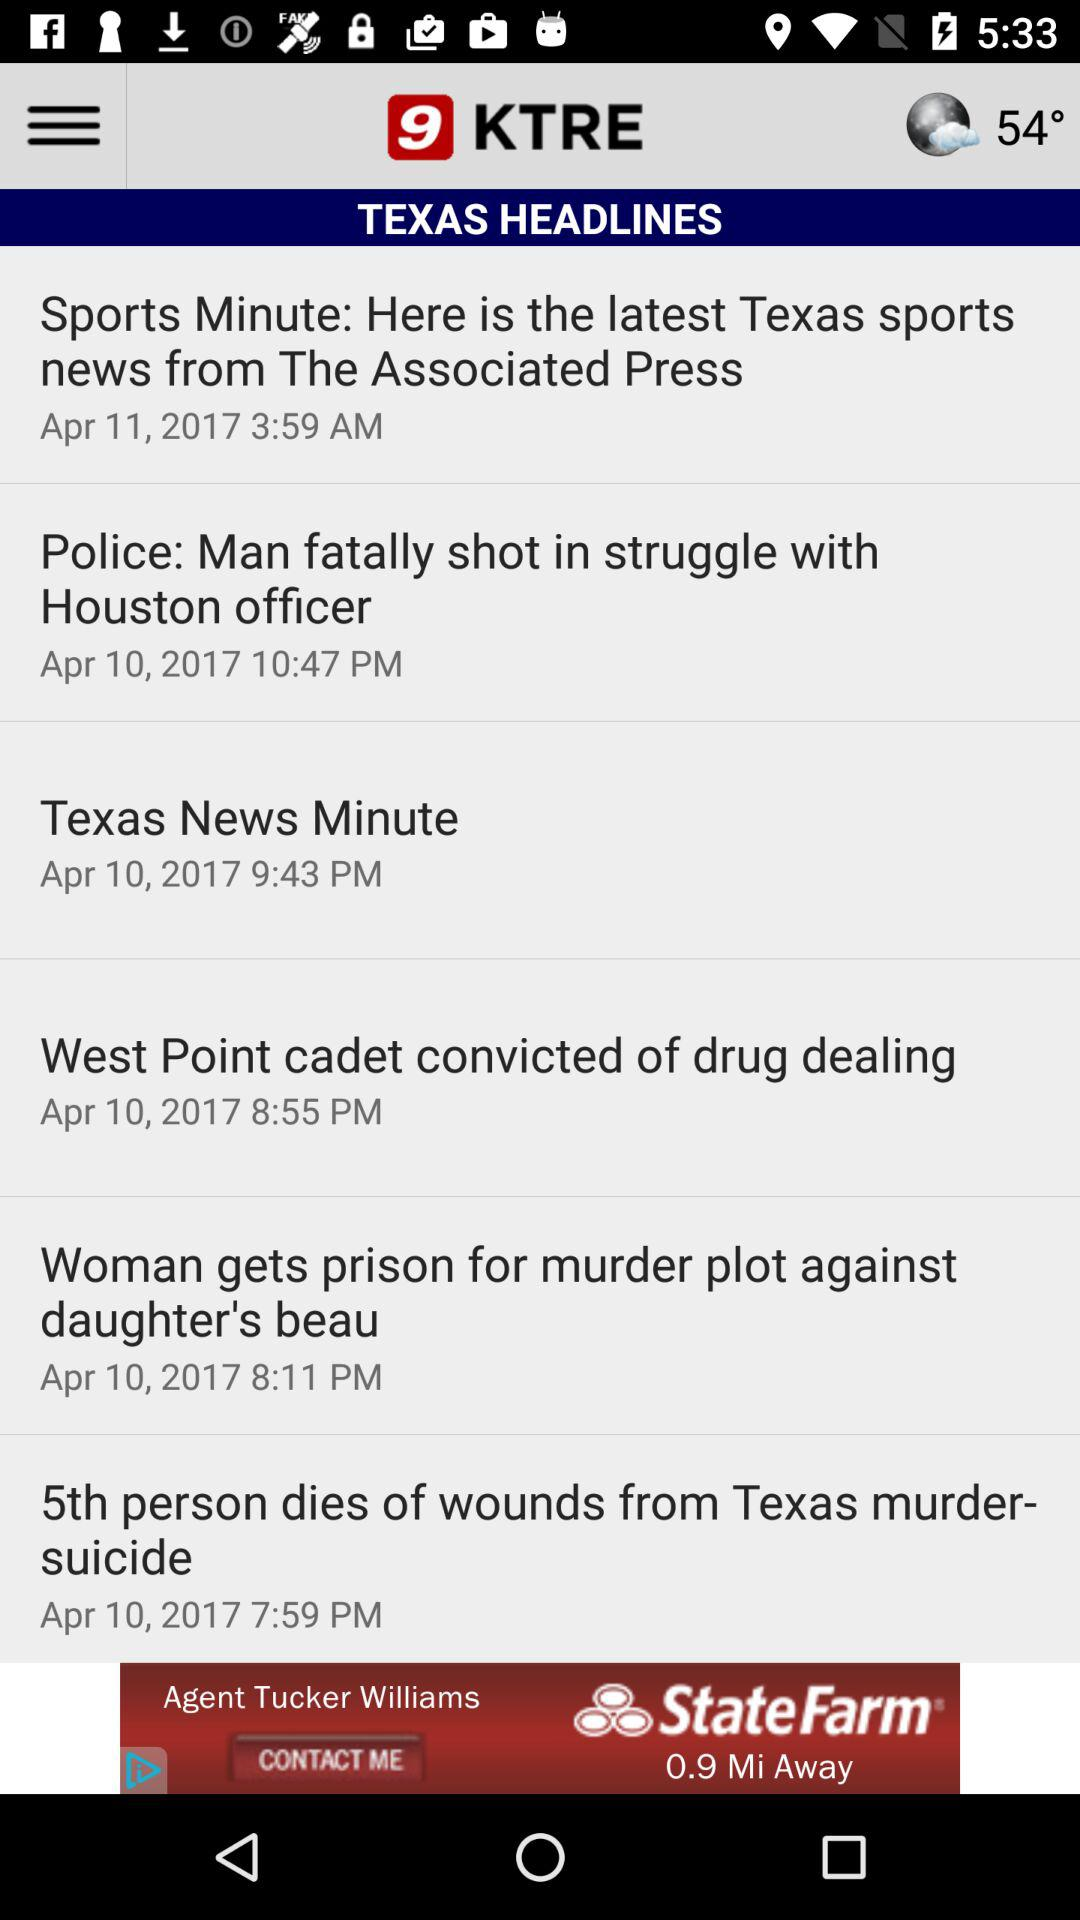Which headline was published on April 10, 2017 at 8:55 p.m.? The headline "West Point cadet convicted of drug dealing" was published on April 10, 2017 at 8:55 p.m. 